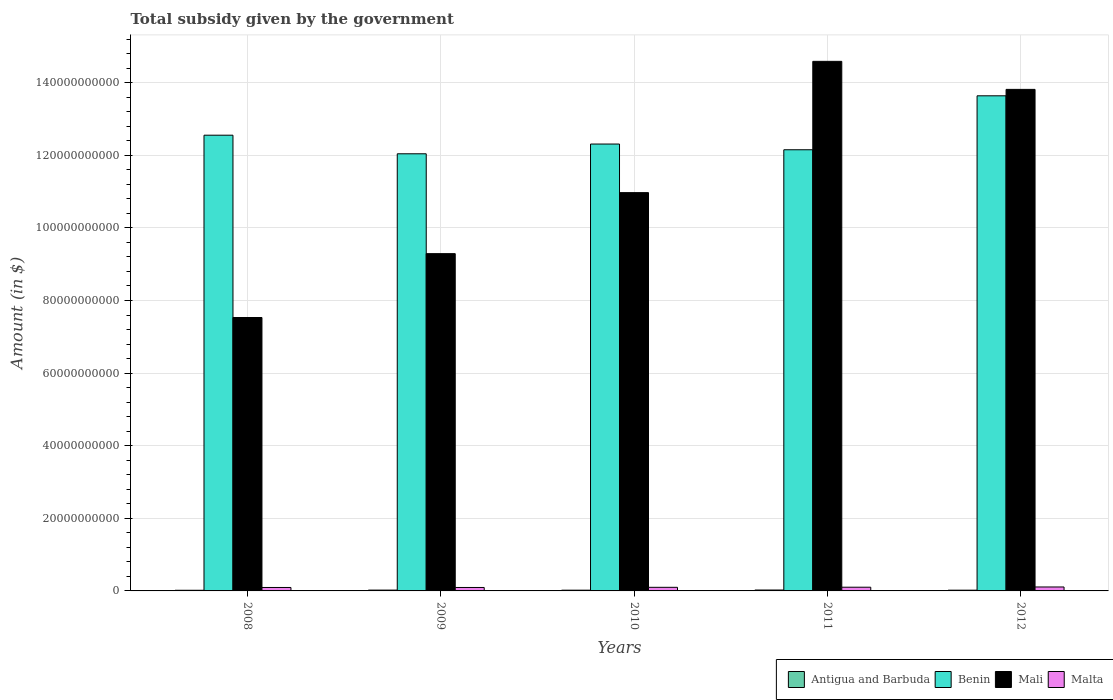How many groups of bars are there?
Ensure brevity in your answer.  5. Are the number of bars on each tick of the X-axis equal?
Your answer should be compact. Yes. How many bars are there on the 5th tick from the left?
Make the answer very short. 4. In how many cases, is the number of bars for a given year not equal to the number of legend labels?
Give a very brief answer. 0. What is the total revenue collected by the government in Benin in 2008?
Provide a short and direct response. 1.26e+11. Across all years, what is the maximum total revenue collected by the government in Antigua and Barbuda?
Offer a terse response. 2.48e+08. Across all years, what is the minimum total revenue collected by the government in Malta?
Provide a short and direct response. 9.47e+08. In which year was the total revenue collected by the government in Antigua and Barbuda maximum?
Your answer should be compact. 2011. In which year was the total revenue collected by the government in Mali minimum?
Provide a short and direct response. 2008. What is the total total revenue collected by the government in Antigua and Barbuda in the graph?
Keep it short and to the point. 1.06e+09. What is the difference between the total revenue collected by the government in Benin in 2009 and that in 2011?
Make the answer very short. -1.11e+09. What is the difference between the total revenue collected by the government in Benin in 2011 and the total revenue collected by the government in Antigua and Barbuda in 2009?
Keep it short and to the point. 1.21e+11. What is the average total revenue collected by the government in Mali per year?
Provide a short and direct response. 1.12e+11. In the year 2012, what is the difference between the total revenue collected by the government in Antigua and Barbuda and total revenue collected by the government in Benin?
Provide a short and direct response. -1.36e+11. What is the ratio of the total revenue collected by the government in Malta in 2009 to that in 2010?
Give a very brief answer. 0.96. Is the difference between the total revenue collected by the government in Antigua and Barbuda in 2011 and 2012 greater than the difference between the total revenue collected by the government in Benin in 2011 and 2012?
Provide a short and direct response. Yes. What is the difference between the highest and the second highest total revenue collected by the government in Antigua and Barbuda?
Keep it short and to the point. 2.34e+07. What is the difference between the highest and the lowest total revenue collected by the government in Benin?
Offer a very short reply. 1.60e+1. What does the 3rd bar from the left in 2010 represents?
Your answer should be compact. Mali. What does the 3rd bar from the right in 2009 represents?
Make the answer very short. Benin. Is it the case that in every year, the sum of the total revenue collected by the government in Mali and total revenue collected by the government in Antigua and Barbuda is greater than the total revenue collected by the government in Benin?
Your response must be concise. No. How many bars are there?
Your answer should be very brief. 20. Does the graph contain any zero values?
Provide a short and direct response. No. Does the graph contain grids?
Offer a terse response. Yes. Where does the legend appear in the graph?
Make the answer very short. Bottom right. What is the title of the graph?
Provide a succinct answer. Total subsidy given by the government. What is the label or title of the Y-axis?
Your answer should be compact. Amount (in $). What is the Amount (in $) in Antigua and Barbuda in 2008?
Provide a short and direct response. 1.78e+08. What is the Amount (in $) in Benin in 2008?
Provide a succinct answer. 1.26e+11. What is the Amount (in $) of Mali in 2008?
Offer a terse response. 7.53e+1. What is the Amount (in $) of Malta in 2008?
Your answer should be compact. 9.47e+08. What is the Amount (in $) of Antigua and Barbuda in 2009?
Ensure brevity in your answer.  2.24e+08. What is the Amount (in $) of Benin in 2009?
Keep it short and to the point. 1.20e+11. What is the Amount (in $) of Mali in 2009?
Give a very brief answer. 9.29e+1. What is the Amount (in $) of Malta in 2009?
Make the answer very short. 9.47e+08. What is the Amount (in $) in Antigua and Barbuda in 2010?
Provide a succinct answer. 2.06e+08. What is the Amount (in $) in Benin in 2010?
Offer a terse response. 1.23e+11. What is the Amount (in $) of Mali in 2010?
Your answer should be very brief. 1.10e+11. What is the Amount (in $) in Malta in 2010?
Keep it short and to the point. 9.90e+08. What is the Amount (in $) of Antigua and Barbuda in 2011?
Your answer should be very brief. 2.48e+08. What is the Amount (in $) in Benin in 2011?
Offer a terse response. 1.22e+11. What is the Amount (in $) in Mali in 2011?
Provide a succinct answer. 1.46e+11. What is the Amount (in $) of Malta in 2011?
Offer a terse response. 1.02e+09. What is the Amount (in $) of Antigua and Barbuda in 2012?
Offer a very short reply. 2.04e+08. What is the Amount (in $) of Benin in 2012?
Keep it short and to the point. 1.36e+11. What is the Amount (in $) in Mali in 2012?
Provide a succinct answer. 1.38e+11. What is the Amount (in $) in Malta in 2012?
Offer a very short reply. 1.09e+09. Across all years, what is the maximum Amount (in $) in Antigua and Barbuda?
Give a very brief answer. 2.48e+08. Across all years, what is the maximum Amount (in $) in Benin?
Offer a terse response. 1.36e+11. Across all years, what is the maximum Amount (in $) in Mali?
Keep it short and to the point. 1.46e+11. Across all years, what is the maximum Amount (in $) in Malta?
Ensure brevity in your answer.  1.09e+09. Across all years, what is the minimum Amount (in $) in Antigua and Barbuda?
Your answer should be compact. 1.78e+08. Across all years, what is the minimum Amount (in $) of Benin?
Your answer should be compact. 1.20e+11. Across all years, what is the minimum Amount (in $) in Mali?
Your answer should be compact. 7.53e+1. Across all years, what is the minimum Amount (in $) in Malta?
Provide a short and direct response. 9.47e+08. What is the total Amount (in $) of Antigua and Barbuda in the graph?
Your answer should be very brief. 1.06e+09. What is the total Amount (in $) of Benin in the graph?
Make the answer very short. 6.27e+11. What is the total Amount (in $) of Mali in the graph?
Offer a very short reply. 5.62e+11. What is the total Amount (in $) in Malta in the graph?
Provide a succinct answer. 4.99e+09. What is the difference between the Amount (in $) of Antigua and Barbuda in 2008 and that in 2009?
Provide a succinct answer. -4.60e+07. What is the difference between the Amount (in $) of Benin in 2008 and that in 2009?
Ensure brevity in your answer.  5.12e+09. What is the difference between the Amount (in $) in Mali in 2008 and that in 2009?
Your answer should be compact. -1.76e+1. What is the difference between the Amount (in $) in Malta in 2008 and that in 2009?
Your response must be concise. -3.06e+05. What is the difference between the Amount (in $) of Antigua and Barbuda in 2008 and that in 2010?
Offer a terse response. -2.71e+07. What is the difference between the Amount (in $) of Benin in 2008 and that in 2010?
Ensure brevity in your answer.  2.43e+09. What is the difference between the Amount (in $) in Mali in 2008 and that in 2010?
Make the answer very short. -3.44e+1. What is the difference between the Amount (in $) in Malta in 2008 and that in 2010?
Keep it short and to the point. -4.33e+07. What is the difference between the Amount (in $) of Antigua and Barbuda in 2008 and that in 2011?
Offer a terse response. -6.94e+07. What is the difference between the Amount (in $) in Benin in 2008 and that in 2011?
Your answer should be very brief. 4.01e+09. What is the difference between the Amount (in $) of Mali in 2008 and that in 2011?
Ensure brevity in your answer.  -7.06e+1. What is the difference between the Amount (in $) in Malta in 2008 and that in 2011?
Your response must be concise. -7.50e+07. What is the difference between the Amount (in $) of Antigua and Barbuda in 2008 and that in 2012?
Keep it short and to the point. -2.55e+07. What is the difference between the Amount (in $) of Benin in 2008 and that in 2012?
Keep it short and to the point. -1.08e+1. What is the difference between the Amount (in $) of Mali in 2008 and that in 2012?
Keep it short and to the point. -6.28e+1. What is the difference between the Amount (in $) in Malta in 2008 and that in 2012?
Give a very brief answer. -1.38e+08. What is the difference between the Amount (in $) in Antigua and Barbuda in 2009 and that in 2010?
Keep it short and to the point. 1.89e+07. What is the difference between the Amount (in $) in Benin in 2009 and that in 2010?
Make the answer very short. -2.69e+09. What is the difference between the Amount (in $) of Mali in 2009 and that in 2010?
Make the answer very short. -1.68e+1. What is the difference between the Amount (in $) in Malta in 2009 and that in 2010?
Your response must be concise. -4.30e+07. What is the difference between the Amount (in $) in Antigua and Barbuda in 2009 and that in 2011?
Provide a succinct answer. -2.34e+07. What is the difference between the Amount (in $) of Benin in 2009 and that in 2011?
Provide a succinct answer. -1.11e+09. What is the difference between the Amount (in $) of Mali in 2009 and that in 2011?
Make the answer very short. -5.30e+1. What is the difference between the Amount (in $) of Malta in 2009 and that in 2011?
Provide a short and direct response. -7.47e+07. What is the difference between the Amount (in $) of Antigua and Barbuda in 2009 and that in 2012?
Provide a short and direct response. 2.05e+07. What is the difference between the Amount (in $) of Benin in 2009 and that in 2012?
Provide a succinct answer. -1.60e+1. What is the difference between the Amount (in $) of Mali in 2009 and that in 2012?
Your answer should be very brief. -4.52e+1. What is the difference between the Amount (in $) in Malta in 2009 and that in 2012?
Provide a succinct answer. -1.38e+08. What is the difference between the Amount (in $) of Antigua and Barbuda in 2010 and that in 2011?
Provide a succinct answer. -4.23e+07. What is the difference between the Amount (in $) in Benin in 2010 and that in 2011?
Provide a succinct answer. 1.58e+09. What is the difference between the Amount (in $) of Mali in 2010 and that in 2011?
Your answer should be very brief. -3.62e+1. What is the difference between the Amount (in $) of Malta in 2010 and that in 2011?
Keep it short and to the point. -3.17e+07. What is the difference between the Amount (in $) in Antigua and Barbuda in 2010 and that in 2012?
Provide a succinct answer. 1.60e+06. What is the difference between the Amount (in $) in Benin in 2010 and that in 2012?
Offer a terse response. -1.33e+1. What is the difference between the Amount (in $) in Mali in 2010 and that in 2012?
Your response must be concise. -2.84e+1. What is the difference between the Amount (in $) of Malta in 2010 and that in 2012?
Your answer should be compact. -9.46e+07. What is the difference between the Amount (in $) of Antigua and Barbuda in 2011 and that in 2012?
Offer a terse response. 4.39e+07. What is the difference between the Amount (in $) in Benin in 2011 and that in 2012?
Make the answer very short. -1.49e+1. What is the difference between the Amount (in $) of Mali in 2011 and that in 2012?
Keep it short and to the point. 7.72e+09. What is the difference between the Amount (in $) in Malta in 2011 and that in 2012?
Offer a very short reply. -6.29e+07. What is the difference between the Amount (in $) in Antigua and Barbuda in 2008 and the Amount (in $) in Benin in 2009?
Your answer should be very brief. -1.20e+11. What is the difference between the Amount (in $) in Antigua and Barbuda in 2008 and the Amount (in $) in Mali in 2009?
Provide a short and direct response. -9.27e+1. What is the difference between the Amount (in $) in Antigua and Barbuda in 2008 and the Amount (in $) in Malta in 2009?
Keep it short and to the point. -7.69e+08. What is the difference between the Amount (in $) of Benin in 2008 and the Amount (in $) of Mali in 2009?
Provide a succinct answer. 3.26e+1. What is the difference between the Amount (in $) of Benin in 2008 and the Amount (in $) of Malta in 2009?
Your response must be concise. 1.25e+11. What is the difference between the Amount (in $) of Mali in 2008 and the Amount (in $) of Malta in 2009?
Your response must be concise. 7.44e+1. What is the difference between the Amount (in $) in Antigua and Barbuda in 2008 and the Amount (in $) in Benin in 2010?
Offer a terse response. -1.23e+11. What is the difference between the Amount (in $) of Antigua and Barbuda in 2008 and the Amount (in $) of Mali in 2010?
Offer a very short reply. -1.10e+11. What is the difference between the Amount (in $) in Antigua and Barbuda in 2008 and the Amount (in $) in Malta in 2010?
Provide a short and direct response. -8.12e+08. What is the difference between the Amount (in $) in Benin in 2008 and the Amount (in $) in Mali in 2010?
Keep it short and to the point. 1.58e+1. What is the difference between the Amount (in $) in Benin in 2008 and the Amount (in $) in Malta in 2010?
Offer a very short reply. 1.25e+11. What is the difference between the Amount (in $) of Mali in 2008 and the Amount (in $) of Malta in 2010?
Offer a terse response. 7.43e+1. What is the difference between the Amount (in $) in Antigua and Barbuda in 2008 and the Amount (in $) in Benin in 2011?
Give a very brief answer. -1.21e+11. What is the difference between the Amount (in $) in Antigua and Barbuda in 2008 and the Amount (in $) in Mali in 2011?
Provide a short and direct response. -1.46e+11. What is the difference between the Amount (in $) of Antigua and Barbuda in 2008 and the Amount (in $) of Malta in 2011?
Your response must be concise. -8.44e+08. What is the difference between the Amount (in $) in Benin in 2008 and the Amount (in $) in Mali in 2011?
Ensure brevity in your answer.  -2.03e+1. What is the difference between the Amount (in $) of Benin in 2008 and the Amount (in $) of Malta in 2011?
Make the answer very short. 1.25e+11. What is the difference between the Amount (in $) in Mali in 2008 and the Amount (in $) in Malta in 2011?
Offer a terse response. 7.43e+1. What is the difference between the Amount (in $) in Antigua and Barbuda in 2008 and the Amount (in $) in Benin in 2012?
Offer a very short reply. -1.36e+11. What is the difference between the Amount (in $) of Antigua and Barbuda in 2008 and the Amount (in $) of Mali in 2012?
Your response must be concise. -1.38e+11. What is the difference between the Amount (in $) of Antigua and Barbuda in 2008 and the Amount (in $) of Malta in 2012?
Provide a succinct answer. -9.07e+08. What is the difference between the Amount (in $) of Benin in 2008 and the Amount (in $) of Mali in 2012?
Your response must be concise. -1.26e+1. What is the difference between the Amount (in $) of Benin in 2008 and the Amount (in $) of Malta in 2012?
Your answer should be very brief. 1.24e+11. What is the difference between the Amount (in $) of Mali in 2008 and the Amount (in $) of Malta in 2012?
Your response must be concise. 7.42e+1. What is the difference between the Amount (in $) in Antigua and Barbuda in 2009 and the Amount (in $) in Benin in 2010?
Ensure brevity in your answer.  -1.23e+11. What is the difference between the Amount (in $) of Antigua and Barbuda in 2009 and the Amount (in $) of Mali in 2010?
Ensure brevity in your answer.  -1.09e+11. What is the difference between the Amount (in $) in Antigua and Barbuda in 2009 and the Amount (in $) in Malta in 2010?
Make the answer very short. -7.66e+08. What is the difference between the Amount (in $) in Benin in 2009 and the Amount (in $) in Mali in 2010?
Provide a short and direct response. 1.07e+1. What is the difference between the Amount (in $) of Benin in 2009 and the Amount (in $) of Malta in 2010?
Offer a very short reply. 1.19e+11. What is the difference between the Amount (in $) in Mali in 2009 and the Amount (in $) in Malta in 2010?
Your answer should be very brief. 9.19e+1. What is the difference between the Amount (in $) in Antigua and Barbuda in 2009 and the Amount (in $) in Benin in 2011?
Provide a succinct answer. -1.21e+11. What is the difference between the Amount (in $) in Antigua and Barbuda in 2009 and the Amount (in $) in Mali in 2011?
Make the answer very short. -1.46e+11. What is the difference between the Amount (in $) of Antigua and Barbuda in 2009 and the Amount (in $) of Malta in 2011?
Keep it short and to the point. -7.98e+08. What is the difference between the Amount (in $) of Benin in 2009 and the Amount (in $) of Mali in 2011?
Your answer should be very brief. -2.55e+1. What is the difference between the Amount (in $) in Benin in 2009 and the Amount (in $) in Malta in 2011?
Provide a short and direct response. 1.19e+11. What is the difference between the Amount (in $) in Mali in 2009 and the Amount (in $) in Malta in 2011?
Offer a terse response. 9.19e+1. What is the difference between the Amount (in $) of Antigua and Barbuda in 2009 and the Amount (in $) of Benin in 2012?
Provide a short and direct response. -1.36e+11. What is the difference between the Amount (in $) of Antigua and Barbuda in 2009 and the Amount (in $) of Mali in 2012?
Keep it short and to the point. -1.38e+11. What is the difference between the Amount (in $) in Antigua and Barbuda in 2009 and the Amount (in $) in Malta in 2012?
Provide a short and direct response. -8.61e+08. What is the difference between the Amount (in $) of Benin in 2009 and the Amount (in $) of Mali in 2012?
Your answer should be compact. -1.77e+1. What is the difference between the Amount (in $) in Benin in 2009 and the Amount (in $) in Malta in 2012?
Your response must be concise. 1.19e+11. What is the difference between the Amount (in $) of Mali in 2009 and the Amount (in $) of Malta in 2012?
Offer a very short reply. 9.18e+1. What is the difference between the Amount (in $) of Antigua and Barbuda in 2010 and the Amount (in $) of Benin in 2011?
Provide a short and direct response. -1.21e+11. What is the difference between the Amount (in $) of Antigua and Barbuda in 2010 and the Amount (in $) of Mali in 2011?
Make the answer very short. -1.46e+11. What is the difference between the Amount (in $) in Antigua and Barbuda in 2010 and the Amount (in $) in Malta in 2011?
Your answer should be compact. -8.17e+08. What is the difference between the Amount (in $) in Benin in 2010 and the Amount (in $) in Mali in 2011?
Ensure brevity in your answer.  -2.28e+1. What is the difference between the Amount (in $) in Benin in 2010 and the Amount (in $) in Malta in 2011?
Your answer should be compact. 1.22e+11. What is the difference between the Amount (in $) in Mali in 2010 and the Amount (in $) in Malta in 2011?
Your answer should be compact. 1.09e+11. What is the difference between the Amount (in $) in Antigua and Barbuda in 2010 and the Amount (in $) in Benin in 2012?
Give a very brief answer. -1.36e+11. What is the difference between the Amount (in $) of Antigua and Barbuda in 2010 and the Amount (in $) of Mali in 2012?
Your answer should be compact. -1.38e+11. What is the difference between the Amount (in $) of Antigua and Barbuda in 2010 and the Amount (in $) of Malta in 2012?
Ensure brevity in your answer.  -8.80e+08. What is the difference between the Amount (in $) in Benin in 2010 and the Amount (in $) in Mali in 2012?
Keep it short and to the point. -1.51e+1. What is the difference between the Amount (in $) in Benin in 2010 and the Amount (in $) in Malta in 2012?
Offer a very short reply. 1.22e+11. What is the difference between the Amount (in $) in Mali in 2010 and the Amount (in $) in Malta in 2012?
Make the answer very short. 1.09e+11. What is the difference between the Amount (in $) of Antigua and Barbuda in 2011 and the Amount (in $) of Benin in 2012?
Make the answer very short. -1.36e+11. What is the difference between the Amount (in $) in Antigua and Barbuda in 2011 and the Amount (in $) in Mali in 2012?
Provide a short and direct response. -1.38e+11. What is the difference between the Amount (in $) of Antigua and Barbuda in 2011 and the Amount (in $) of Malta in 2012?
Offer a very short reply. -8.37e+08. What is the difference between the Amount (in $) of Benin in 2011 and the Amount (in $) of Mali in 2012?
Make the answer very short. -1.66e+1. What is the difference between the Amount (in $) of Benin in 2011 and the Amount (in $) of Malta in 2012?
Offer a terse response. 1.20e+11. What is the difference between the Amount (in $) of Mali in 2011 and the Amount (in $) of Malta in 2012?
Provide a succinct answer. 1.45e+11. What is the average Amount (in $) of Antigua and Barbuda per year?
Provide a succinct answer. 2.12e+08. What is the average Amount (in $) of Benin per year?
Make the answer very short. 1.25e+11. What is the average Amount (in $) in Mali per year?
Provide a succinct answer. 1.12e+11. What is the average Amount (in $) in Malta per year?
Give a very brief answer. 9.98e+08. In the year 2008, what is the difference between the Amount (in $) in Antigua and Barbuda and Amount (in $) in Benin?
Make the answer very short. -1.25e+11. In the year 2008, what is the difference between the Amount (in $) in Antigua and Barbuda and Amount (in $) in Mali?
Provide a short and direct response. -7.51e+1. In the year 2008, what is the difference between the Amount (in $) in Antigua and Barbuda and Amount (in $) in Malta?
Provide a short and direct response. -7.69e+08. In the year 2008, what is the difference between the Amount (in $) in Benin and Amount (in $) in Mali?
Ensure brevity in your answer.  5.02e+1. In the year 2008, what is the difference between the Amount (in $) of Benin and Amount (in $) of Malta?
Your answer should be compact. 1.25e+11. In the year 2008, what is the difference between the Amount (in $) in Mali and Amount (in $) in Malta?
Your response must be concise. 7.44e+1. In the year 2009, what is the difference between the Amount (in $) in Antigua and Barbuda and Amount (in $) in Benin?
Make the answer very short. -1.20e+11. In the year 2009, what is the difference between the Amount (in $) of Antigua and Barbuda and Amount (in $) of Mali?
Make the answer very short. -9.27e+1. In the year 2009, what is the difference between the Amount (in $) of Antigua and Barbuda and Amount (in $) of Malta?
Provide a succinct answer. -7.23e+08. In the year 2009, what is the difference between the Amount (in $) in Benin and Amount (in $) in Mali?
Your response must be concise. 2.75e+1. In the year 2009, what is the difference between the Amount (in $) of Benin and Amount (in $) of Malta?
Give a very brief answer. 1.19e+11. In the year 2009, what is the difference between the Amount (in $) in Mali and Amount (in $) in Malta?
Your response must be concise. 9.20e+1. In the year 2010, what is the difference between the Amount (in $) in Antigua and Barbuda and Amount (in $) in Benin?
Make the answer very short. -1.23e+11. In the year 2010, what is the difference between the Amount (in $) in Antigua and Barbuda and Amount (in $) in Mali?
Offer a very short reply. -1.10e+11. In the year 2010, what is the difference between the Amount (in $) of Antigua and Barbuda and Amount (in $) of Malta?
Offer a terse response. -7.85e+08. In the year 2010, what is the difference between the Amount (in $) in Benin and Amount (in $) in Mali?
Provide a succinct answer. 1.34e+1. In the year 2010, what is the difference between the Amount (in $) of Benin and Amount (in $) of Malta?
Offer a terse response. 1.22e+11. In the year 2010, what is the difference between the Amount (in $) of Mali and Amount (in $) of Malta?
Keep it short and to the point. 1.09e+11. In the year 2011, what is the difference between the Amount (in $) in Antigua and Barbuda and Amount (in $) in Benin?
Ensure brevity in your answer.  -1.21e+11. In the year 2011, what is the difference between the Amount (in $) in Antigua and Barbuda and Amount (in $) in Mali?
Provide a succinct answer. -1.46e+11. In the year 2011, what is the difference between the Amount (in $) in Antigua and Barbuda and Amount (in $) in Malta?
Give a very brief answer. -7.74e+08. In the year 2011, what is the difference between the Amount (in $) of Benin and Amount (in $) of Mali?
Offer a very short reply. -2.44e+1. In the year 2011, what is the difference between the Amount (in $) in Benin and Amount (in $) in Malta?
Make the answer very short. 1.20e+11. In the year 2011, what is the difference between the Amount (in $) of Mali and Amount (in $) of Malta?
Offer a terse response. 1.45e+11. In the year 2012, what is the difference between the Amount (in $) in Antigua and Barbuda and Amount (in $) in Benin?
Offer a very short reply. -1.36e+11. In the year 2012, what is the difference between the Amount (in $) of Antigua and Barbuda and Amount (in $) of Mali?
Offer a terse response. -1.38e+11. In the year 2012, what is the difference between the Amount (in $) in Antigua and Barbuda and Amount (in $) in Malta?
Offer a very short reply. -8.81e+08. In the year 2012, what is the difference between the Amount (in $) of Benin and Amount (in $) of Mali?
Provide a short and direct response. -1.77e+09. In the year 2012, what is the difference between the Amount (in $) in Benin and Amount (in $) in Malta?
Provide a short and direct response. 1.35e+11. In the year 2012, what is the difference between the Amount (in $) in Mali and Amount (in $) in Malta?
Make the answer very short. 1.37e+11. What is the ratio of the Amount (in $) of Antigua and Barbuda in 2008 to that in 2009?
Offer a terse response. 0.8. What is the ratio of the Amount (in $) of Benin in 2008 to that in 2009?
Your answer should be very brief. 1.04. What is the ratio of the Amount (in $) in Mali in 2008 to that in 2009?
Your response must be concise. 0.81. What is the ratio of the Amount (in $) of Antigua and Barbuda in 2008 to that in 2010?
Offer a terse response. 0.87. What is the ratio of the Amount (in $) of Benin in 2008 to that in 2010?
Ensure brevity in your answer.  1.02. What is the ratio of the Amount (in $) in Mali in 2008 to that in 2010?
Your answer should be very brief. 0.69. What is the ratio of the Amount (in $) in Malta in 2008 to that in 2010?
Make the answer very short. 0.96. What is the ratio of the Amount (in $) in Antigua and Barbuda in 2008 to that in 2011?
Provide a short and direct response. 0.72. What is the ratio of the Amount (in $) in Benin in 2008 to that in 2011?
Give a very brief answer. 1.03. What is the ratio of the Amount (in $) of Mali in 2008 to that in 2011?
Your answer should be very brief. 0.52. What is the ratio of the Amount (in $) in Malta in 2008 to that in 2011?
Your answer should be very brief. 0.93. What is the ratio of the Amount (in $) in Antigua and Barbuda in 2008 to that in 2012?
Give a very brief answer. 0.87. What is the ratio of the Amount (in $) in Benin in 2008 to that in 2012?
Offer a very short reply. 0.92. What is the ratio of the Amount (in $) of Mali in 2008 to that in 2012?
Provide a succinct answer. 0.55. What is the ratio of the Amount (in $) of Malta in 2008 to that in 2012?
Your response must be concise. 0.87. What is the ratio of the Amount (in $) in Antigua and Barbuda in 2009 to that in 2010?
Make the answer very short. 1.09. What is the ratio of the Amount (in $) in Benin in 2009 to that in 2010?
Your response must be concise. 0.98. What is the ratio of the Amount (in $) in Mali in 2009 to that in 2010?
Keep it short and to the point. 0.85. What is the ratio of the Amount (in $) in Malta in 2009 to that in 2010?
Ensure brevity in your answer.  0.96. What is the ratio of the Amount (in $) in Antigua and Barbuda in 2009 to that in 2011?
Ensure brevity in your answer.  0.91. What is the ratio of the Amount (in $) of Benin in 2009 to that in 2011?
Your answer should be very brief. 0.99. What is the ratio of the Amount (in $) of Mali in 2009 to that in 2011?
Ensure brevity in your answer.  0.64. What is the ratio of the Amount (in $) in Malta in 2009 to that in 2011?
Keep it short and to the point. 0.93. What is the ratio of the Amount (in $) in Antigua and Barbuda in 2009 to that in 2012?
Provide a succinct answer. 1.1. What is the ratio of the Amount (in $) of Benin in 2009 to that in 2012?
Give a very brief answer. 0.88. What is the ratio of the Amount (in $) of Mali in 2009 to that in 2012?
Provide a succinct answer. 0.67. What is the ratio of the Amount (in $) in Malta in 2009 to that in 2012?
Provide a short and direct response. 0.87. What is the ratio of the Amount (in $) of Antigua and Barbuda in 2010 to that in 2011?
Offer a very short reply. 0.83. What is the ratio of the Amount (in $) in Benin in 2010 to that in 2011?
Give a very brief answer. 1.01. What is the ratio of the Amount (in $) of Mali in 2010 to that in 2011?
Give a very brief answer. 0.75. What is the ratio of the Amount (in $) of Antigua and Barbuda in 2010 to that in 2012?
Offer a terse response. 1.01. What is the ratio of the Amount (in $) in Benin in 2010 to that in 2012?
Your answer should be compact. 0.9. What is the ratio of the Amount (in $) of Mali in 2010 to that in 2012?
Make the answer very short. 0.79. What is the ratio of the Amount (in $) in Malta in 2010 to that in 2012?
Give a very brief answer. 0.91. What is the ratio of the Amount (in $) in Antigua and Barbuda in 2011 to that in 2012?
Give a very brief answer. 1.22. What is the ratio of the Amount (in $) of Benin in 2011 to that in 2012?
Your answer should be very brief. 0.89. What is the ratio of the Amount (in $) in Mali in 2011 to that in 2012?
Your answer should be very brief. 1.06. What is the ratio of the Amount (in $) of Malta in 2011 to that in 2012?
Your answer should be compact. 0.94. What is the difference between the highest and the second highest Amount (in $) in Antigua and Barbuda?
Your answer should be compact. 2.34e+07. What is the difference between the highest and the second highest Amount (in $) in Benin?
Give a very brief answer. 1.08e+1. What is the difference between the highest and the second highest Amount (in $) of Mali?
Offer a terse response. 7.72e+09. What is the difference between the highest and the second highest Amount (in $) in Malta?
Your answer should be very brief. 6.29e+07. What is the difference between the highest and the lowest Amount (in $) of Antigua and Barbuda?
Your response must be concise. 6.94e+07. What is the difference between the highest and the lowest Amount (in $) of Benin?
Your answer should be compact. 1.60e+1. What is the difference between the highest and the lowest Amount (in $) in Mali?
Keep it short and to the point. 7.06e+1. What is the difference between the highest and the lowest Amount (in $) of Malta?
Offer a terse response. 1.38e+08. 